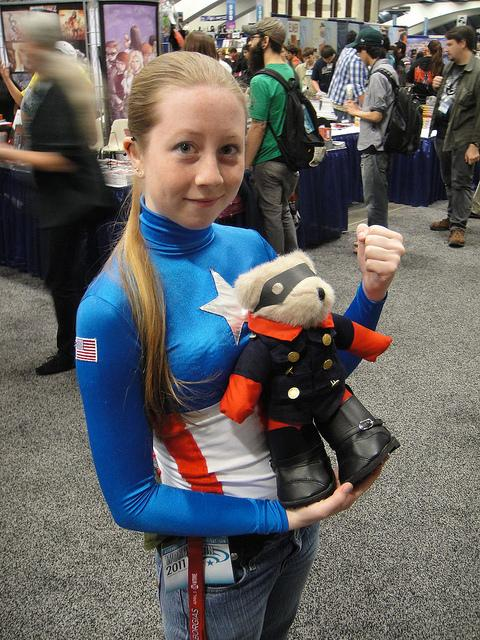In which sort of event does this woman pose? cosplay 